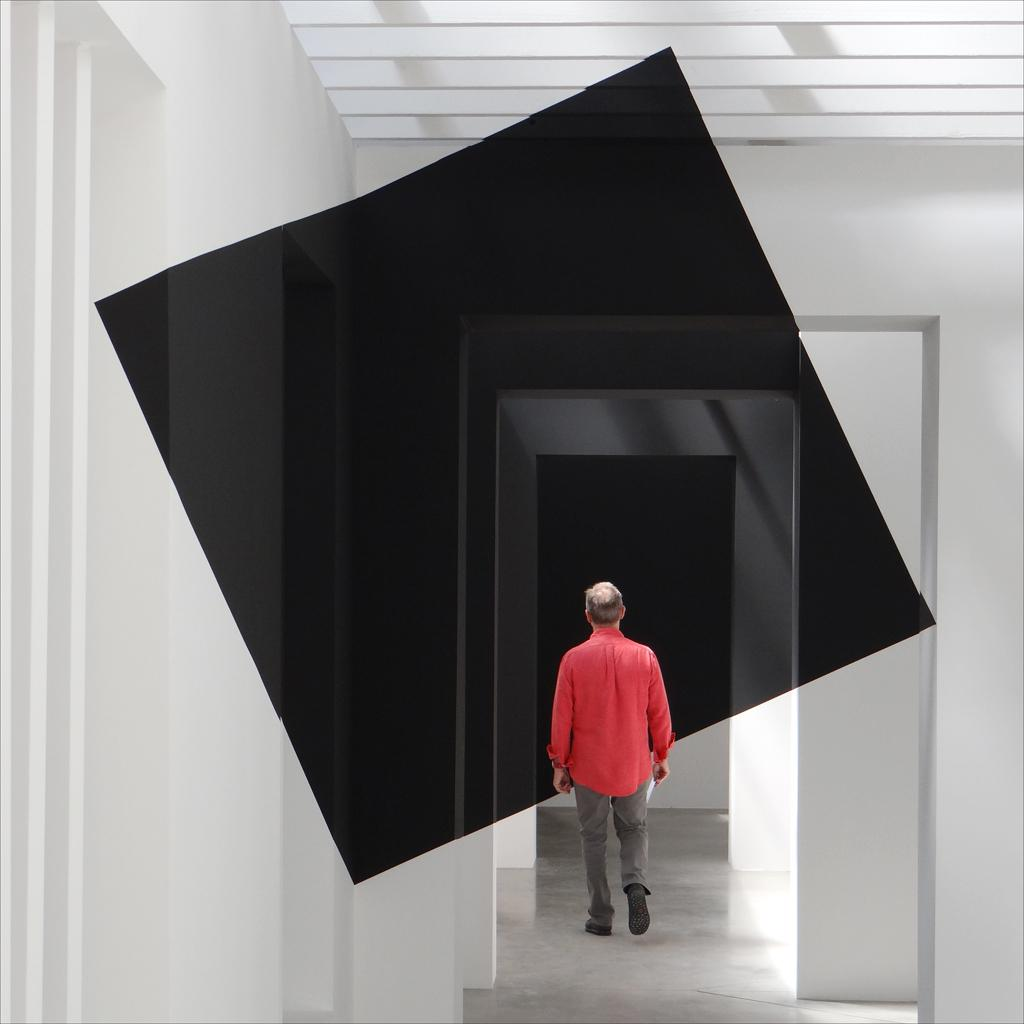What is the person in the image wearing? The person is wearing a red and grey color dress. What is the person doing in the image? The person is standing. What color are the walls in the image? The walls in the image are white. What is the color of the object in the image? The object in the image is black in color. What day of the week is the person in the image referring to? The image does not provide any information about the day of the week, nor does it show the person referring to any day. 